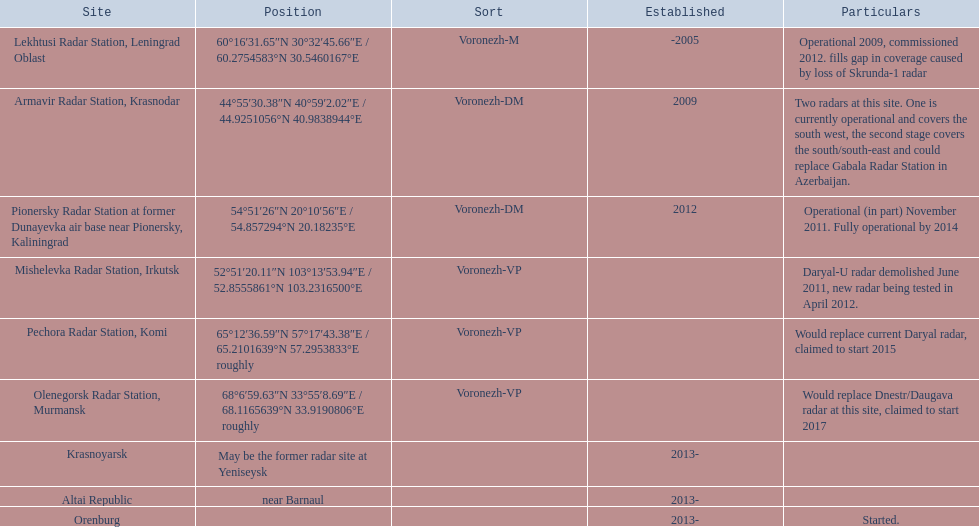What year built is at the top? -2005. 